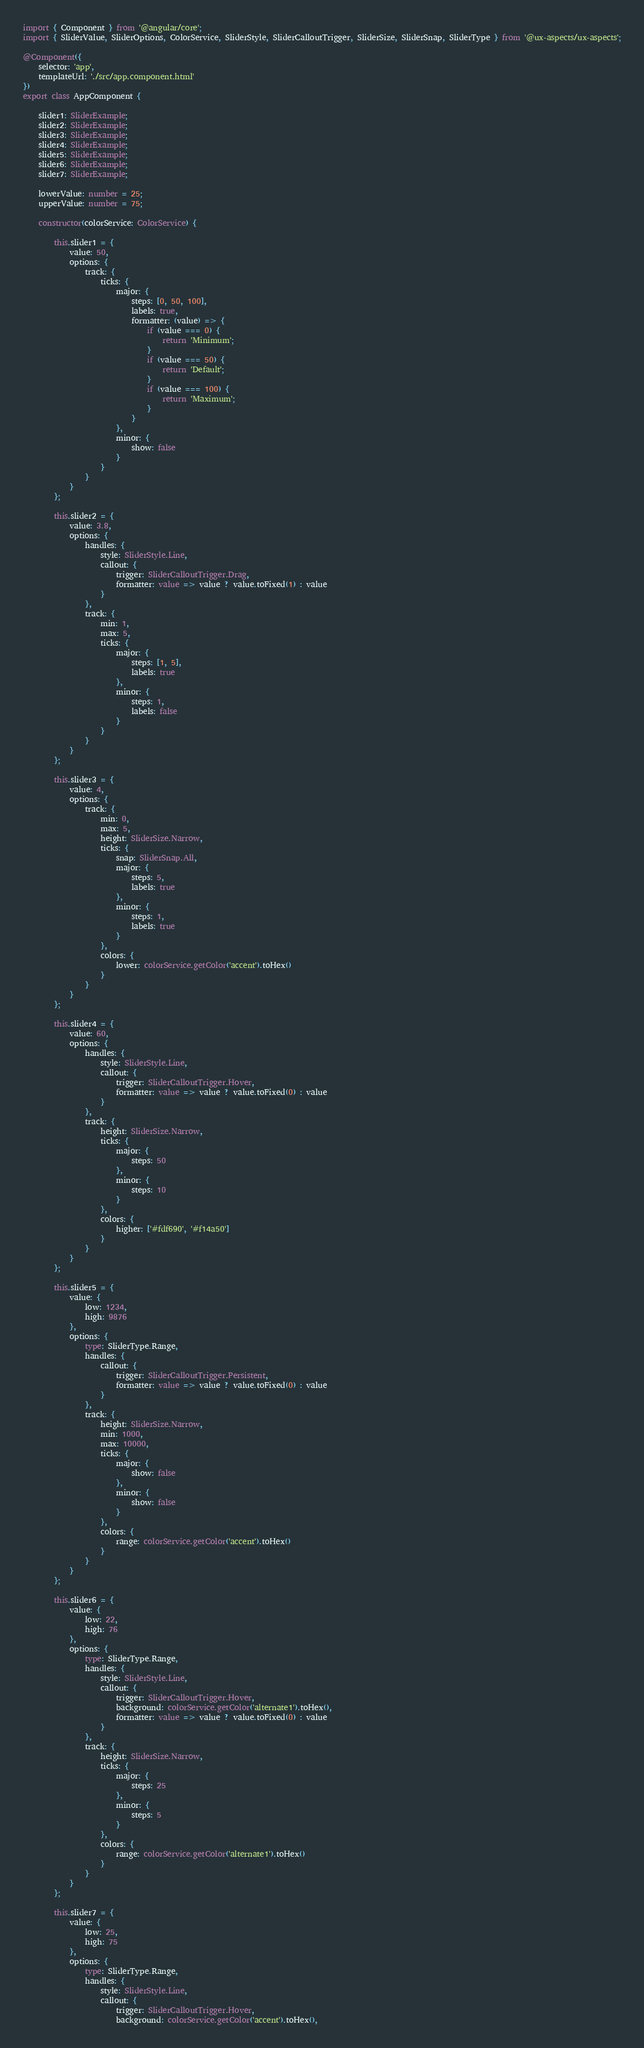<code> <loc_0><loc_0><loc_500><loc_500><_TypeScript_>import { Component } from '@angular/core';
import { SliderValue, SliderOptions, ColorService, SliderStyle, SliderCalloutTrigger, SliderSize, SliderSnap, SliderType } from '@ux-aspects/ux-aspects';

@Component({
    selector: 'app',
    templateUrl: './src/app.component.html'
})
export class AppComponent {

    slider1: SliderExample;
    slider2: SliderExample;
    slider3: SliderExample;
    slider4: SliderExample;
    slider5: SliderExample;
    slider6: SliderExample;
    slider7: SliderExample;

    lowerValue: number = 25;
    upperValue: number = 75;

    constructor(colorService: ColorService) {

        this.slider1 = {
            value: 50,
            options: {
                track: {
                    ticks: {
                        major: {
                            steps: [0, 50, 100],
                            labels: true,
                            formatter: (value) => {
                                if (value === 0) {
                                    return 'Minimum';
                                }
                                if (value === 50) {
                                    return 'Default';
                                }
                                if (value === 100) {
                                    return 'Maximum';
                                }
                            }
                        },
                        minor: {
                            show: false
                        }
                    }
                }
            }
        };

        this.slider2 = {
            value: 3.8,
            options: {
                handles: {
                    style: SliderStyle.Line,
                    callout: {
                        trigger: SliderCalloutTrigger.Drag,
                        formatter: value => value ? value.toFixed(1) : value
                    }
                },
                track: {
                    min: 1,
                    max: 5,
                    ticks: {
                        major: {
                            steps: [1, 5],
                            labels: true
                        },
                        minor: {
                            steps: 1,
                            labels: false
                        }
                    }
                }
            }
        };

        this.slider3 = {
            value: 4,
            options: {
                track: {
                    min: 0,
                    max: 5,
                    height: SliderSize.Narrow,
                    ticks: {
                        snap: SliderSnap.All,
                        major: {
                            steps: 5,
                            labels: true
                        },
                        minor: {
                            steps: 1,
                            labels: true
                        }
                    },
                    colors: {
                        lower: colorService.getColor('accent').toHex()
                    }
                }
            }
        };

        this.slider4 = {
            value: 60,
            options: {
                handles: {
                    style: SliderStyle.Line,
                    callout: {
                        trigger: SliderCalloutTrigger.Hover,
                        formatter: value => value ? value.toFixed(0) : value
                    }
                },
                track: {
                    height: SliderSize.Narrow,
                    ticks: {
                        major: {
                            steps: 50
                        },
                        minor: {
                            steps: 10
                        }
                    },
                    colors: {
                        higher: ['#fdf690', '#f14a50']
                    }
                }
            }
        };

        this.slider5 = {
            value: {
                low: 1234,
                high: 9876
            },
            options: {
                type: SliderType.Range,
                handles: {
                    callout: {
                        trigger: SliderCalloutTrigger.Persistent,
                        formatter: value => value ? value.toFixed(0) : value
                    }
                },
                track: {
                    height: SliderSize.Narrow,
                    min: 1000,
                    max: 10000,
                    ticks: {
                        major: {
                            show: false
                        },
                        minor: {
                            show: false
                        }
                    },
                    colors: {
                        range: colorService.getColor('accent').toHex()
                    }
                }
            }
        };

        this.slider6 = {
            value: {
                low: 22,
                high: 76
            },
            options: {
                type: SliderType.Range,
                handles: {
                    style: SliderStyle.Line,
                    callout: {
                        trigger: SliderCalloutTrigger.Hover,
                        background: colorService.getColor('alternate1').toHex(),
                        formatter: value => value ? value.toFixed(0) : value
                    }
                },
                track: {
                    height: SliderSize.Narrow,
                    ticks: {
                        major: {
                            steps: 25
                        },
                        minor: {
                            steps: 5
                        }
                    },
                    colors: {
                        range: colorService.getColor('alternate1').toHex()
                    }
                }
            }
        };

        this.slider7 = {
            value: {
                low: 25,
                high: 75
            },
            options: {
                type: SliderType.Range,
                handles: {
                    style: SliderStyle.Line,
                    callout: {
                        trigger: SliderCalloutTrigger.Hover,
                        background: colorService.getColor('accent').toHex(),</code> 